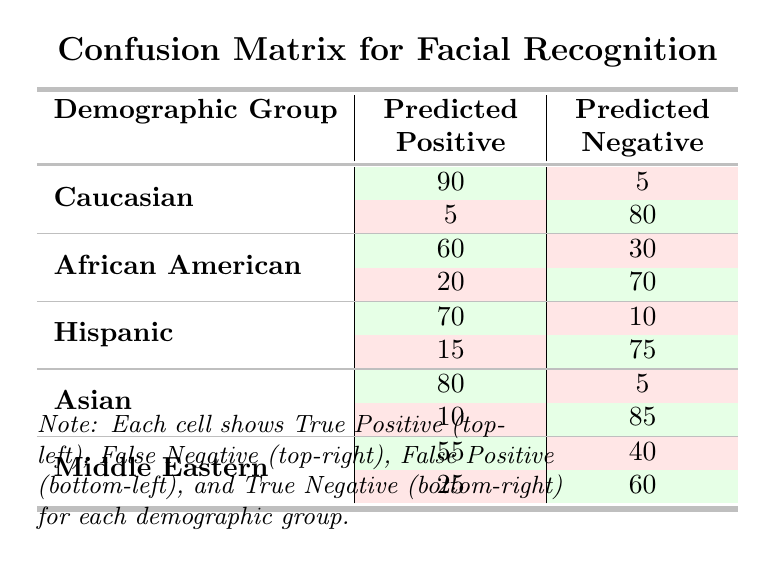What is the true positive rate for the Caucasian group? The true positive rate can be calculated by dividing the true positives by the total number of actual positive cases. For the Caucasian group, this is 90 true positives out of (90 true positives + 5 false negatives) = 95, which gives us 90/95 = 0.947 or approximately 94.7%.
Answer: 94.7% What is the total number of true negatives across all demographic groups? To find the total number of true negatives, we add the true negatives from each group: 80 (Caucasian) + 70 (African American) + 75 (Hispanic) + 85 (Asian) + 60 (Middle Eastern) = 370.
Answer: 370 Does the Hispanic group have more false positives or false negatives? The Hispanic group has 15 false positives and 10 false negatives. Since 15 is greater than 10, the statement is true that the Hispanic group has more false positives than false negatives.
Answer: Yes Which demographic group has the lowest true positive count? By examining the true positive counts from each group: Caucasian (90), African American (60), Hispanic (70), Asian (80), and Middle Eastern (55), the Middle Eastern group has the lowest count with 55 true positives.
Answer: Middle Eastern Calculate the average false negative for all groups. To find the average false negative, we sum the false negatives: 5 (Caucasian) + 30 (African American) + 10 (Hispanic) + 5 (Asian) + 40 (Middle Eastern) = 90. With five demographic groups, the average is 90/5 = 18.
Answer: 18 Is the true positive rate for the Asian group higher than that for the African American group? The true positive rate for the Asian group is 80 out of (80 + 5) = 85 or 94.1%, while for the African American group, it is 60 out of (60 + 30) = 90 or 66.7%. Since 94.1% is greater than 66.7%, the Asian group has a higher true positive rate.
Answer: Yes What is the difference in true negatives between the Caucasian and Middle Eastern groups? The true negatives for the Caucasian group are 80, and for the Middle Eastern group, they are 60. Therefore, the difference is 80 - 60 = 20.
Answer: 20 Which group has the highest rate of false negatives? The false negatives for each group are: Caucasian (5), African American (30), Hispanic (10), Asian (5), and Middle Eastern (40). The Middle Eastern group has the highest false negatives at 40.
Answer: Middle Eastern 